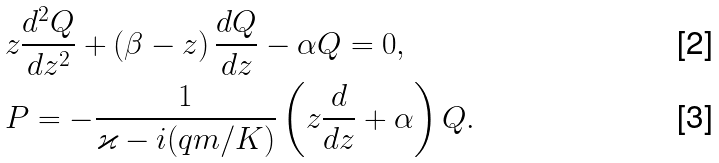<formula> <loc_0><loc_0><loc_500><loc_500>& z \frac { d ^ { 2 } Q } { d z ^ { 2 } } + \left ( \beta - z \right ) \frac { d Q } { d z } - \alpha Q = 0 , \, \\ & P = - \frac { 1 } { \varkappa - i ( q m / K ) } \left ( z \frac { d } { d z } + \alpha \right ) Q .</formula> 